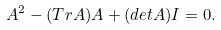Convert formula to latex. <formula><loc_0><loc_0><loc_500><loc_500>A ^ { 2 } - ( T r A ) A + ( d e t A ) I = 0 .</formula> 